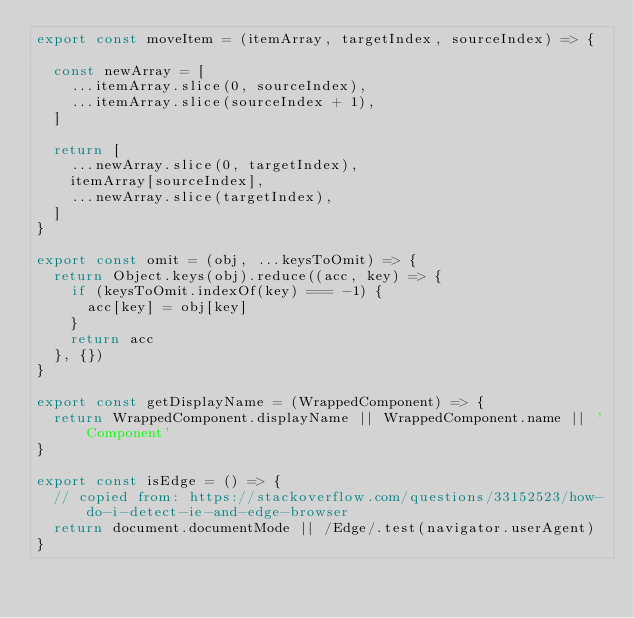Convert code to text. <code><loc_0><loc_0><loc_500><loc_500><_JavaScript_>export const moveItem = (itemArray, targetIndex, sourceIndex) => {

  const newArray = [
    ...itemArray.slice(0, sourceIndex),
    ...itemArray.slice(sourceIndex + 1),
  ]

  return [
    ...newArray.slice(0, targetIndex),
    itemArray[sourceIndex],
    ...newArray.slice(targetIndex),
  ]
}

export const omit = (obj, ...keysToOmit) => {
  return Object.keys(obj).reduce((acc, key) => {
    if (keysToOmit.indexOf(key) === -1) {
      acc[key] = obj[key]
    }
    return acc
  }, {})
}

export const getDisplayName = (WrappedComponent) => {
  return WrappedComponent.displayName || WrappedComponent.name || 'Component'
}

export const isEdge = () => {
  // copied from: https://stackoverflow.com/questions/33152523/how-do-i-detect-ie-and-edge-browser
  return document.documentMode || /Edge/.test(navigator.userAgent)
}
</code> 